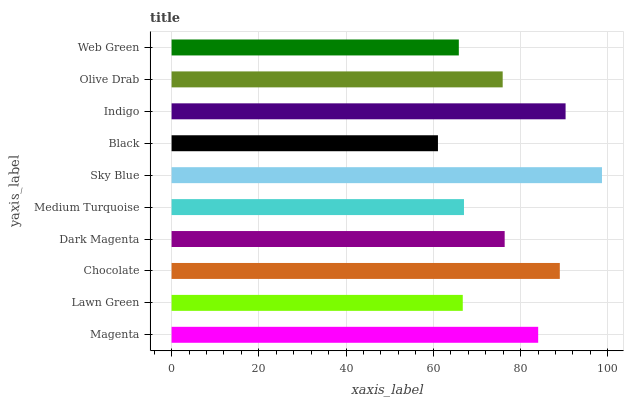Is Black the minimum?
Answer yes or no. Yes. Is Sky Blue the maximum?
Answer yes or no. Yes. Is Lawn Green the minimum?
Answer yes or no. No. Is Lawn Green the maximum?
Answer yes or no. No. Is Magenta greater than Lawn Green?
Answer yes or no. Yes. Is Lawn Green less than Magenta?
Answer yes or no. Yes. Is Lawn Green greater than Magenta?
Answer yes or no. No. Is Magenta less than Lawn Green?
Answer yes or no. No. Is Dark Magenta the high median?
Answer yes or no. Yes. Is Olive Drab the low median?
Answer yes or no. Yes. Is Olive Drab the high median?
Answer yes or no. No. Is Black the low median?
Answer yes or no. No. 